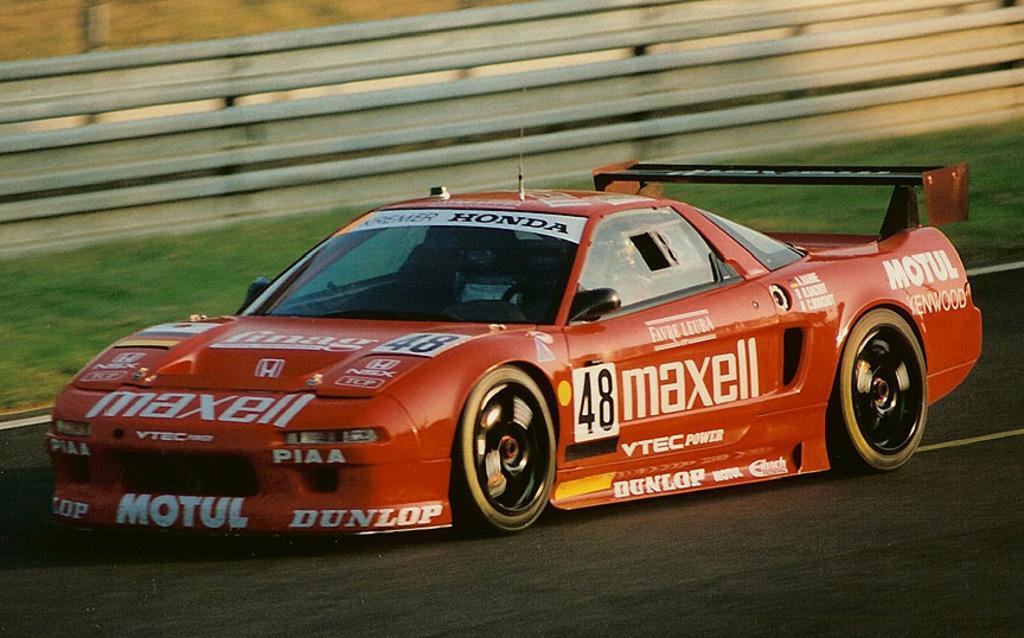In one or two sentences, can you explain what this image depicts? In this image we can see a person is riding car on the road. In the background we can see fence and grass on the ground. 